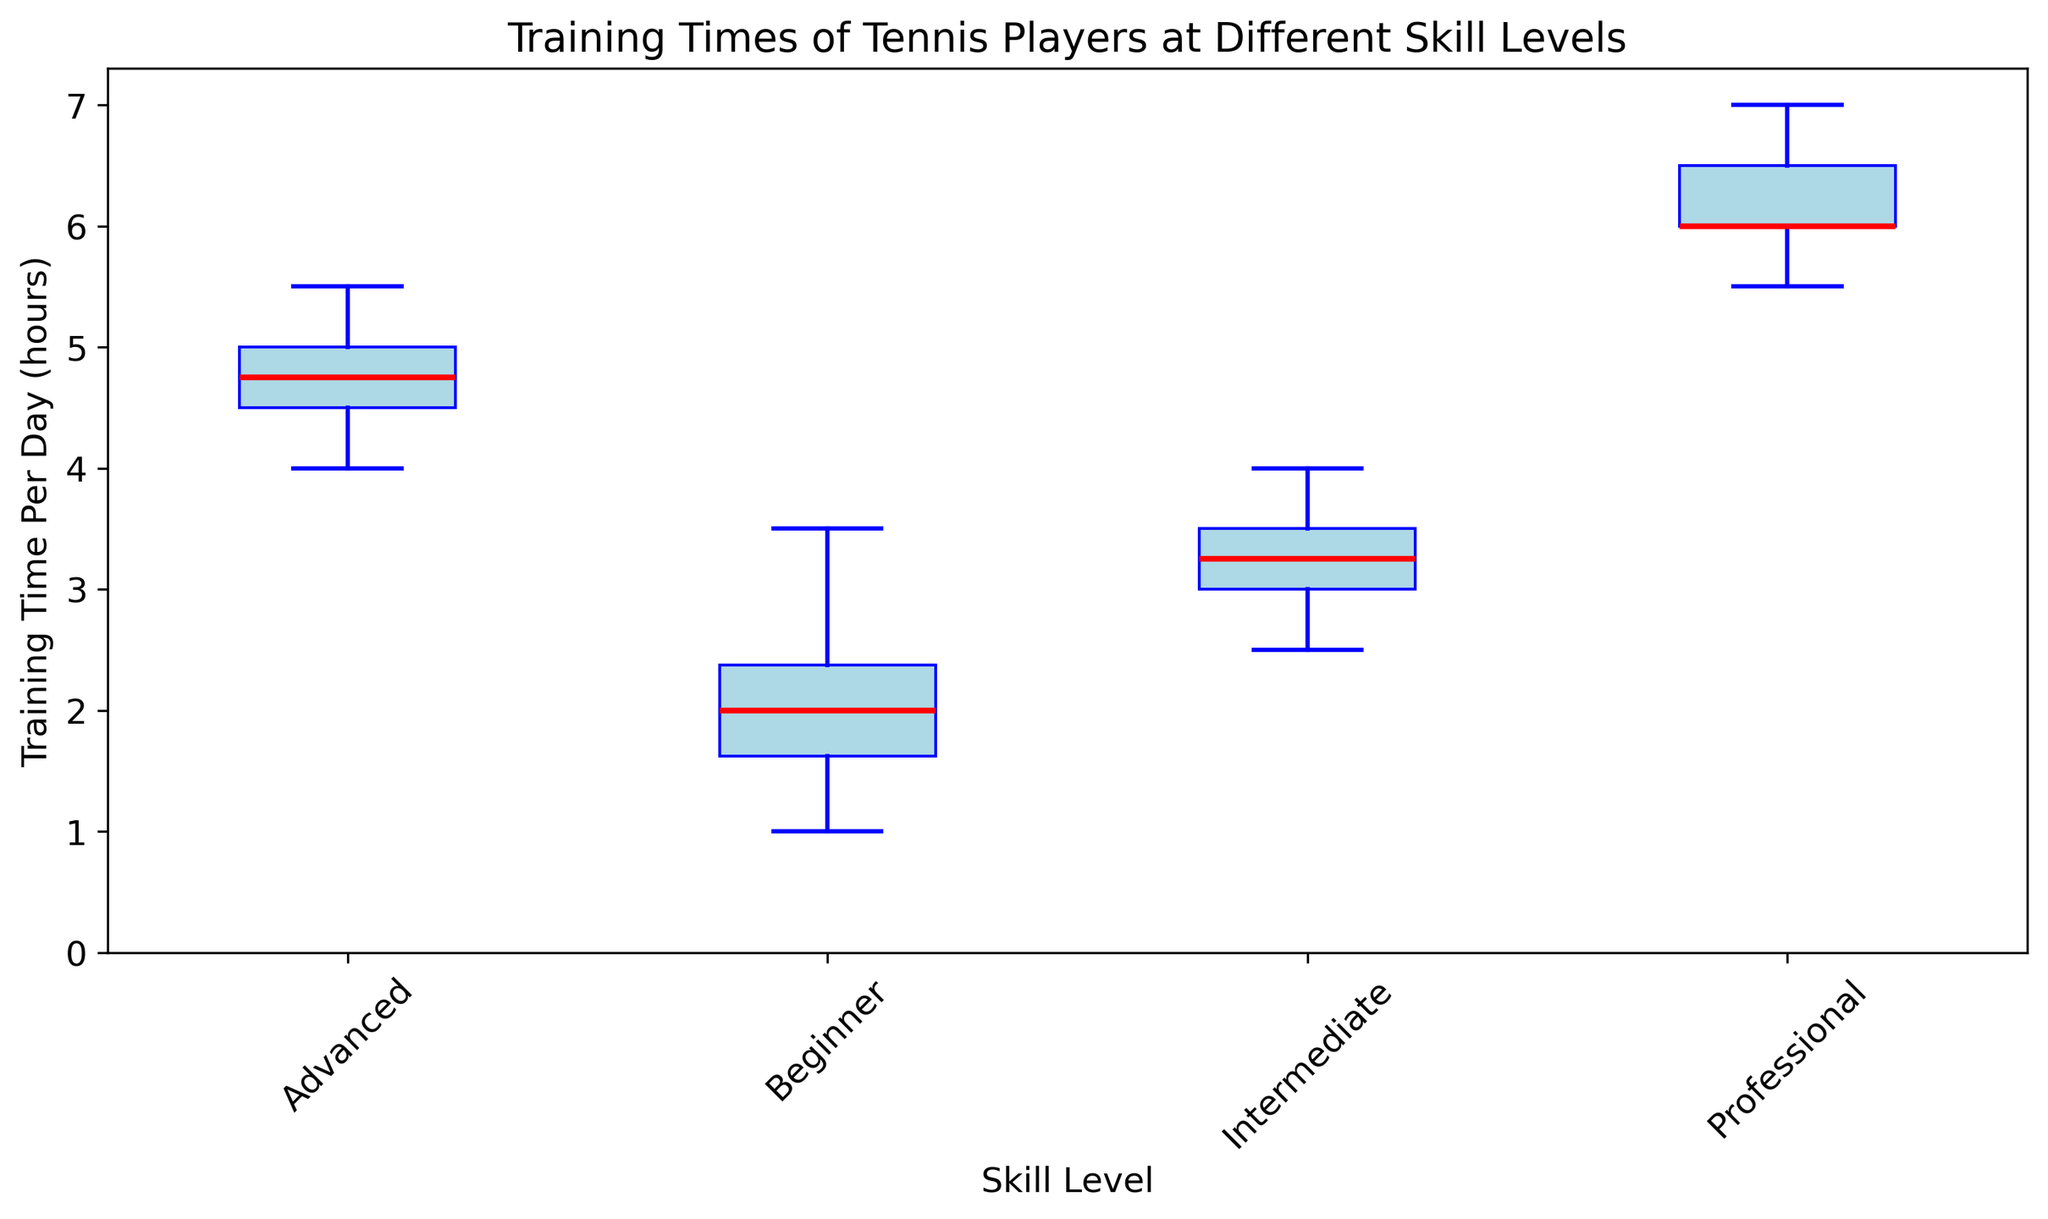What's the median training time for Intermediate players? First, locate the box representing Intermediate players. The median is marked by the red line inside the box. For Intermediate players, the median line is at 3 hours of training per day.
Answer: 3 How does the training time of Beginner players compare to Professional players? We look at the range of training times for both skill levels. Beginner players range mostly between 1 to 3.5 hours, while Professional players range between 5.5 and 7 hours. Therefore, Professional players have significantly higher training times than Beginner players.
Answer: Professional players train more Which skill level has the widest range of training times? Examine the length of each "whisker" (lines extending from the boxes). Beginner players have the whiskers ranging from 1 to 3.5, making a range of 2.5 hours. The other ranges are: Intermediate (2.5–4), Advanced (4–5.5), and Professional (5.5–7). Beginners have the widest range.
Answer: Beginner What is the interquartile range (IQR) for Advanced players? The IQR is the range between the first quartile (bottom of the box) and the third quartile (top of the box). For Advanced players, the box ranges from 4.5 to 5, so the IQR is 5.5 - 4.5 = 1 hour.
Answer: 1 How much more do Professional players train per day on average compared to Beginner players? Locate the median lines for both Professional and Beginner. Professional players' median is at 6 hours, while Beginners' is at 2 hours. The difference is 6 - 2 = 4 hours.
Answer: 4 hours Which skill level has the highest median training time? Look for the highest position of the red median lines in the boxes. The median line of Professional players is the highest at 6 hours.
Answer: Professional Is the median training time for Intermediate players higher than that of Advanced players? Observe the median lines in both the Intermediate and Advanced boxes. The median for Intermediate is at 3 hours, while for Advanced, it is at 4.5 hours. Therefore, the median for Advanced players is higher.
Answer: No How do the median training times of Intermediate and Advanced players compare? The median training time for Intermediate players is at 3 hours, and for Advanced players, it is at 4.5 hours. Therefore, Advanced players' median is 1.5 hours higher than that of Intermediate players.
Answer: Advanced players train 1.5 hours more 